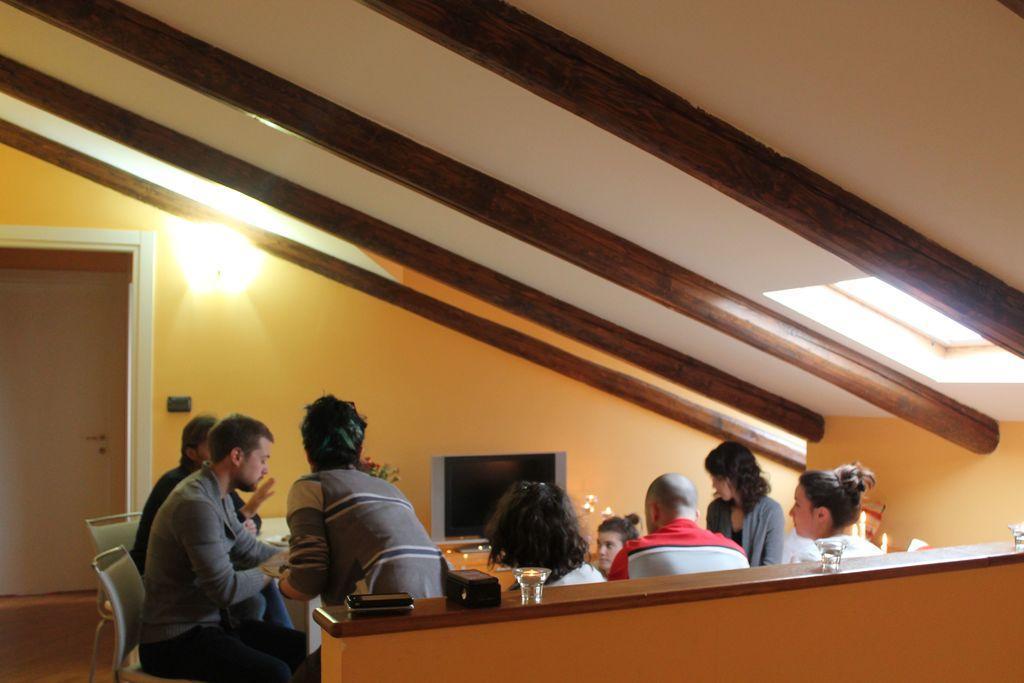How would you summarize this image in a sentence or two? In this picture we can see a group of people, here we can see a television, chairs, table, glasses, lights and some objects and in the background we can see a wall, door. 